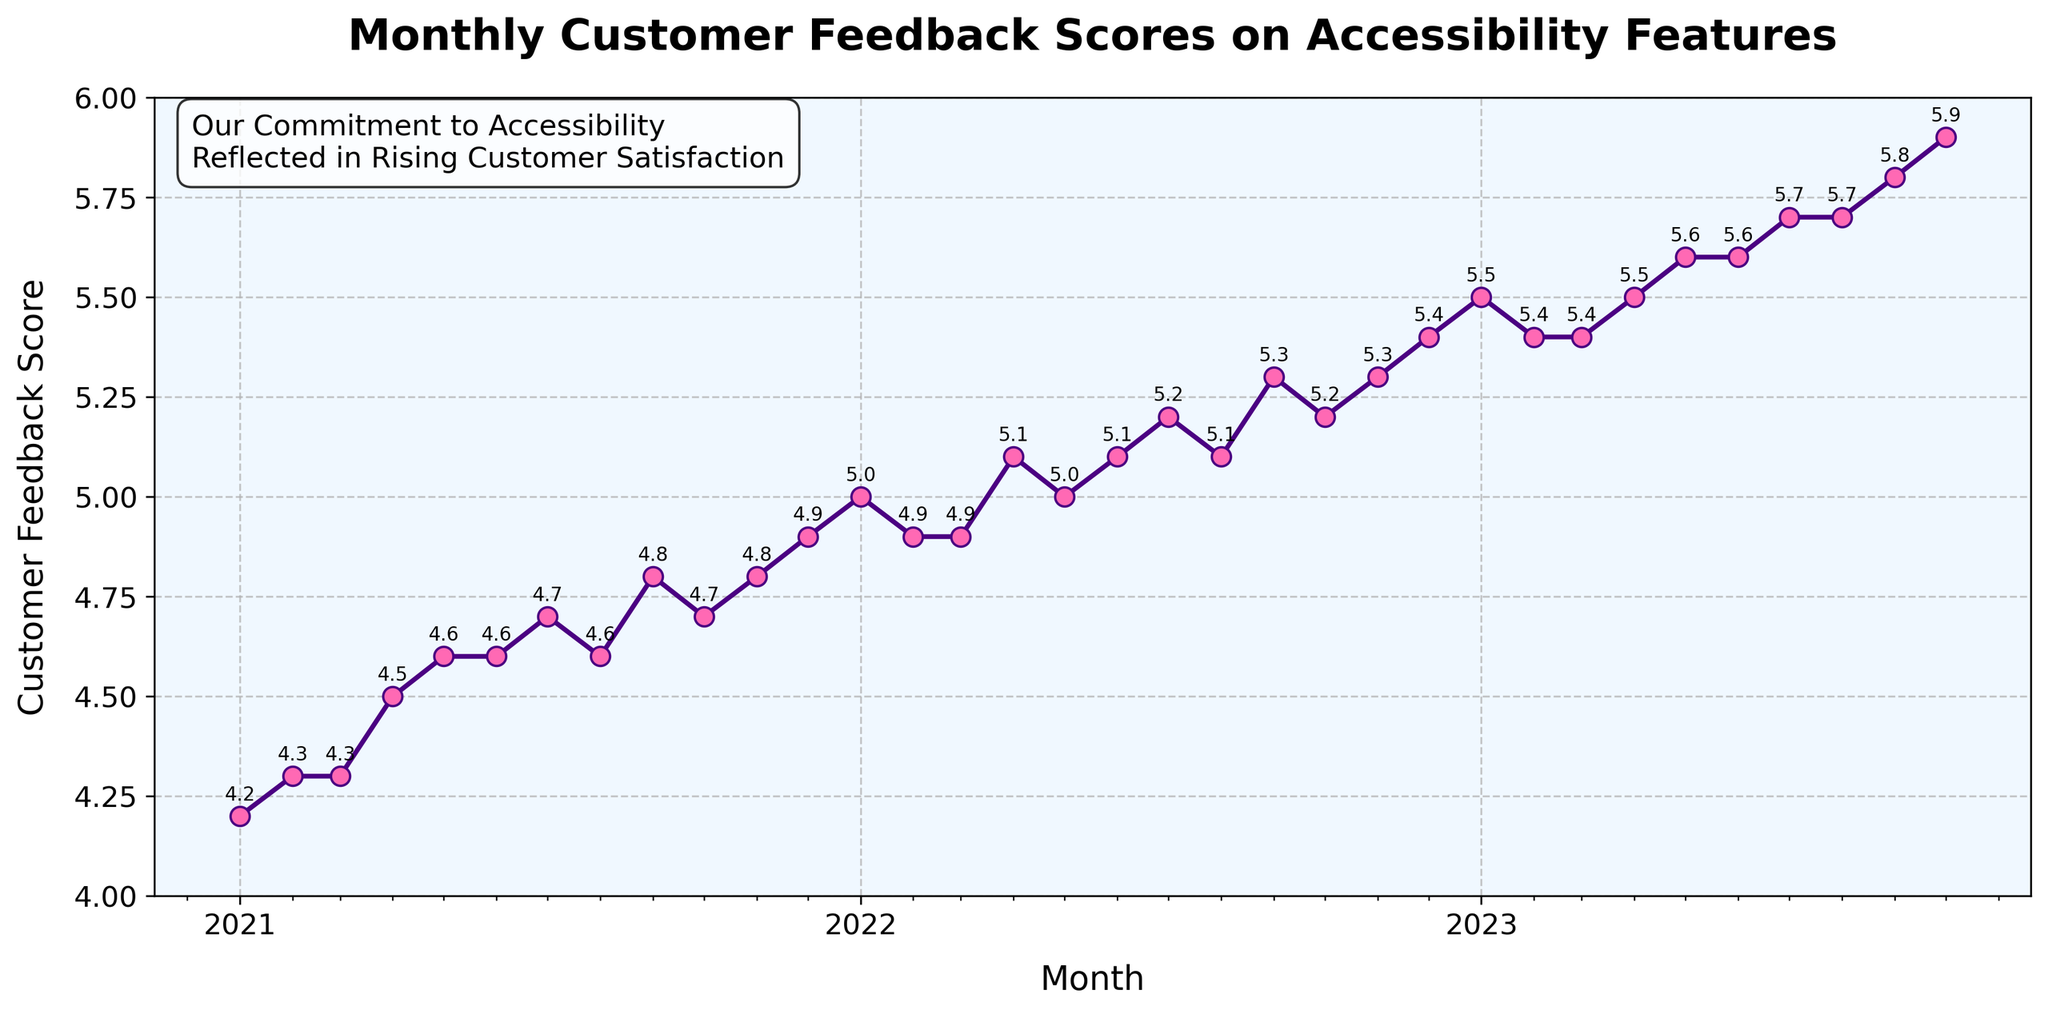what is the title of the plot? The title of the plot is displayed at the top, in a bold font. The title summarizes the content.
Answer: Monthly Customer Feedback Scores on Accessibility Features what is the vertical axis labeled? The vertical axis label is located on the left side of the plot and indicates the measured values.
Answer: Customer Feedback Score What period does the plot cover? The horizontal axis indicates the range of months covered by the plot. The first data point is in January 2021 and the last data point is in October 2023.
Answer: January 2021 to October 2023 How does the customer feedback score change from January 2021 to January 2022? From January 2021 to January 2022, the customer feedback score starts at 4.2 and increases to 5.0. This is seen by observing the plotted points and their associated annotations.
Answer: It increases from 4.2 to 5.0 What month shows the highest customer feedback score and what is the score? We see the highest score by identifying the peak in the data points. The highest point on the graph is in October 2023.
Answer: October 2023, 5.9 Which months show a score above 5.5? We identify months above 5.5 by looking at points above this threshold on the vertical axis. These are May 2023 to October 2023.
Answer: May 2023 to October 2023 Between which two consecutive months is the largest increase in feedback score observed? We determine the largest increase by comparing the differences between consecutive points. The largest increase is between December 2022 and January 2023 (from 5.4 to 5.5).
Answer: December 2022 to January 2023 On average, how did the customer feedback score change from 2021 to 2023? The average change can be found by comparing the starting score (2021) to the ending score (2023) and dividing the change by the number of years. Starting at 4.2 in January 2021 and ending at 5.9 in October 2023 means a net change of 1.7 over approximately 3 years.
Answer: 0.57 per year (approx.) What is the annotation added on the plot, and what does it signify? The annotation is a text box at the top left corner, highlighting a key message noting an improvement in customer satisfaction due to the company’s commitment to accessibility. This is a marketing emphasis.
Answer: Our Commitment to Accessibility Reflected in Rising Customer Satisfaction 